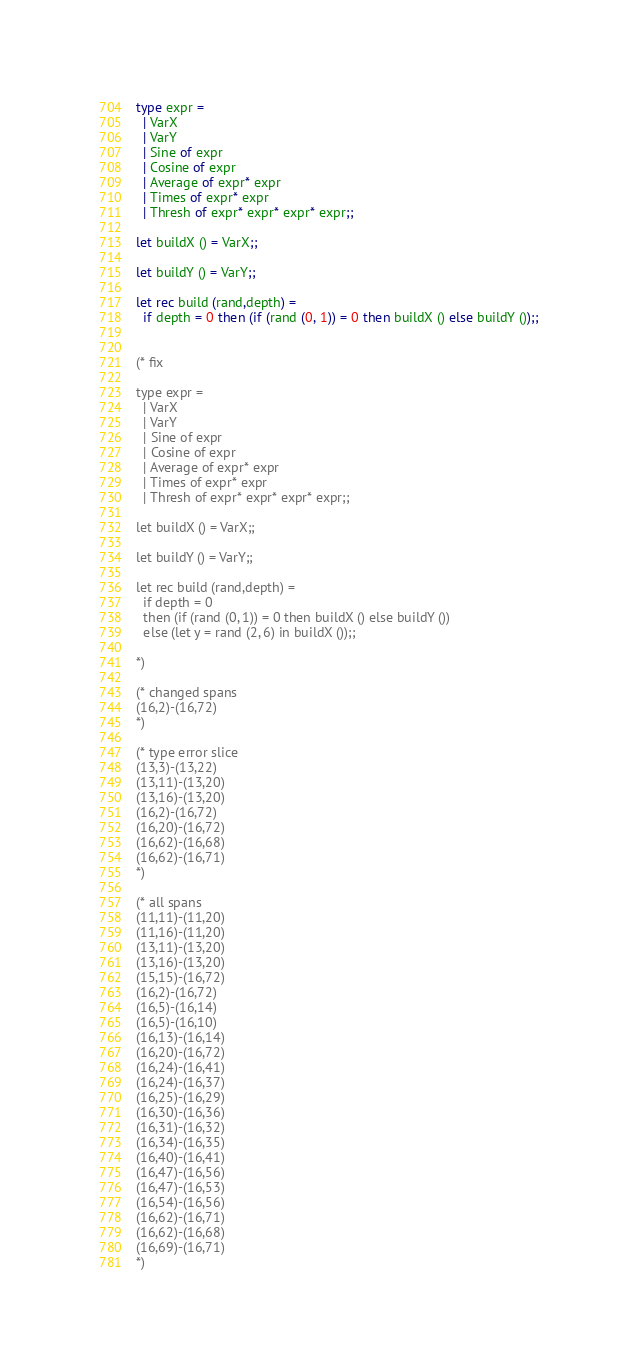Convert code to text. <code><loc_0><loc_0><loc_500><loc_500><_OCaml_>
type expr =
  | VarX
  | VarY
  | Sine of expr
  | Cosine of expr
  | Average of expr* expr
  | Times of expr* expr
  | Thresh of expr* expr* expr* expr;;

let buildX () = VarX;;

let buildY () = VarY;;

let rec build (rand,depth) =
  if depth = 0 then (if (rand (0, 1)) = 0 then buildX () else buildY ());;


(* fix

type expr =
  | VarX
  | VarY
  | Sine of expr
  | Cosine of expr
  | Average of expr* expr
  | Times of expr* expr
  | Thresh of expr* expr* expr* expr;;

let buildX () = VarX;;

let buildY () = VarY;;

let rec build (rand,depth) =
  if depth = 0
  then (if (rand (0, 1)) = 0 then buildX () else buildY ())
  else (let y = rand (2, 6) in buildX ());;

*)

(* changed spans
(16,2)-(16,72)
*)

(* type error slice
(13,3)-(13,22)
(13,11)-(13,20)
(13,16)-(13,20)
(16,2)-(16,72)
(16,20)-(16,72)
(16,62)-(16,68)
(16,62)-(16,71)
*)

(* all spans
(11,11)-(11,20)
(11,16)-(11,20)
(13,11)-(13,20)
(13,16)-(13,20)
(15,15)-(16,72)
(16,2)-(16,72)
(16,5)-(16,14)
(16,5)-(16,10)
(16,13)-(16,14)
(16,20)-(16,72)
(16,24)-(16,41)
(16,24)-(16,37)
(16,25)-(16,29)
(16,30)-(16,36)
(16,31)-(16,32)
(16,34)-(16,35)
(16,40)-(16,41)
(16,47)-(16,56)
(16,47)-(16,53)
(16,54)-(16,56)
(16,62)-(16,71)
(16,62)-(16,68)
(16,69)-(16,71)
*)
</code> 